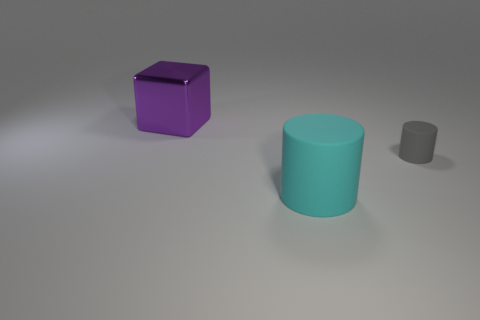Is there any other thing that is the same shape as the small rubber object?
Provide a short and direct response. Yes. How many matte things are there?
Provide a short and direct response. 2. Are there any gray rubber objects of the same size as the gray rubber cylinder?
Provide a short and direct response. No. Do the purple thing and the cylinder that is behind the cyan cylinder have the same material?
Offer a terse response. No. There is a large object that is behind the cyan thing; what material is it?
Provide a succinct answer. Metal. The cyan matte object is what size?
Offer a terse response. Large. There is a object that is to the left of the big cyan matte object; is it the same size as the matte thing on the left side of the gray matte cylinder?
Offer a terse response. Yes. The other matte object that is the same shape as the large cyan thing is what size?
Give a very brief answer. Small. Is the size of the purple shiny block the same as the rubber thing that is in front of the small matte object?
Your answer should be very brief. Yes. There is a large object on the left side of the big cyan matte object; are there any purple shiny objects that are on the left side of it?
Ensure brevity in your answer.  No. 